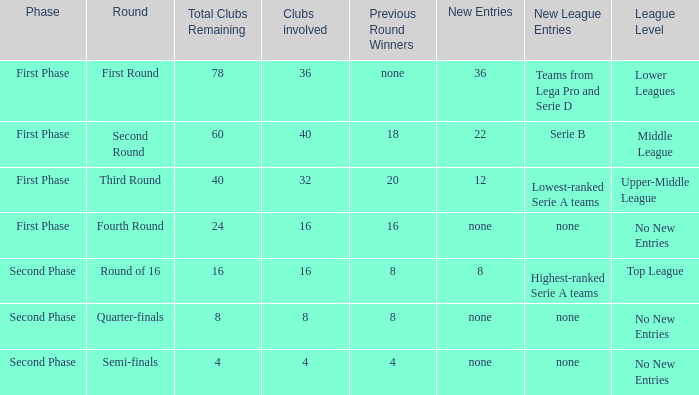What new entries can be discovered in the third round, known as the round name? 12.0. 